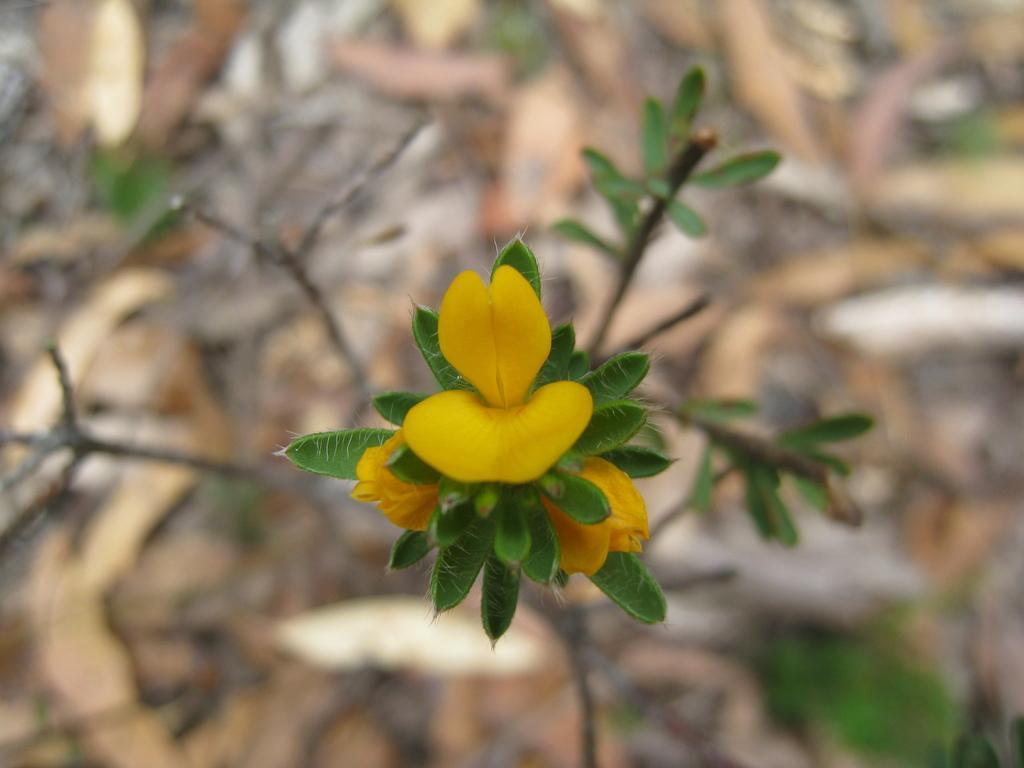Describe this image in one or two sentences. In the center of the picture there is a plant and there are flowers. The background is blurred. 